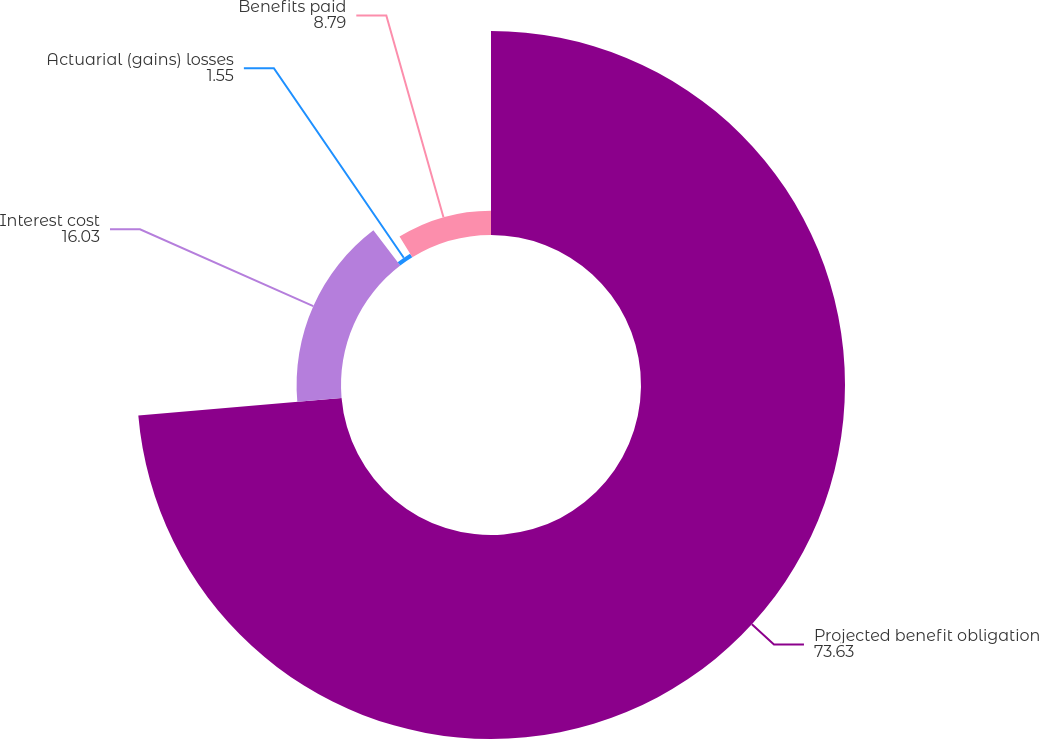Convert chart to OTSL. <chart><loc_0><loc_0><loc_500><loc_500><pie_chart><fcel>Projected benefit obligation<fcel>Interest cost<fcel>Actuarial (gains) losses<fcel>Benefits paid<nl><fcel>73.63%<fcel>16.03%<fcel>1.55%<fcel>8.79%<nl></chart> 